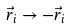<formula> <loc_0><loc_0><loc_500><loc_500>\vec { r } _ { i } \rightarrow - \vec { r } _ { i }</formula> 